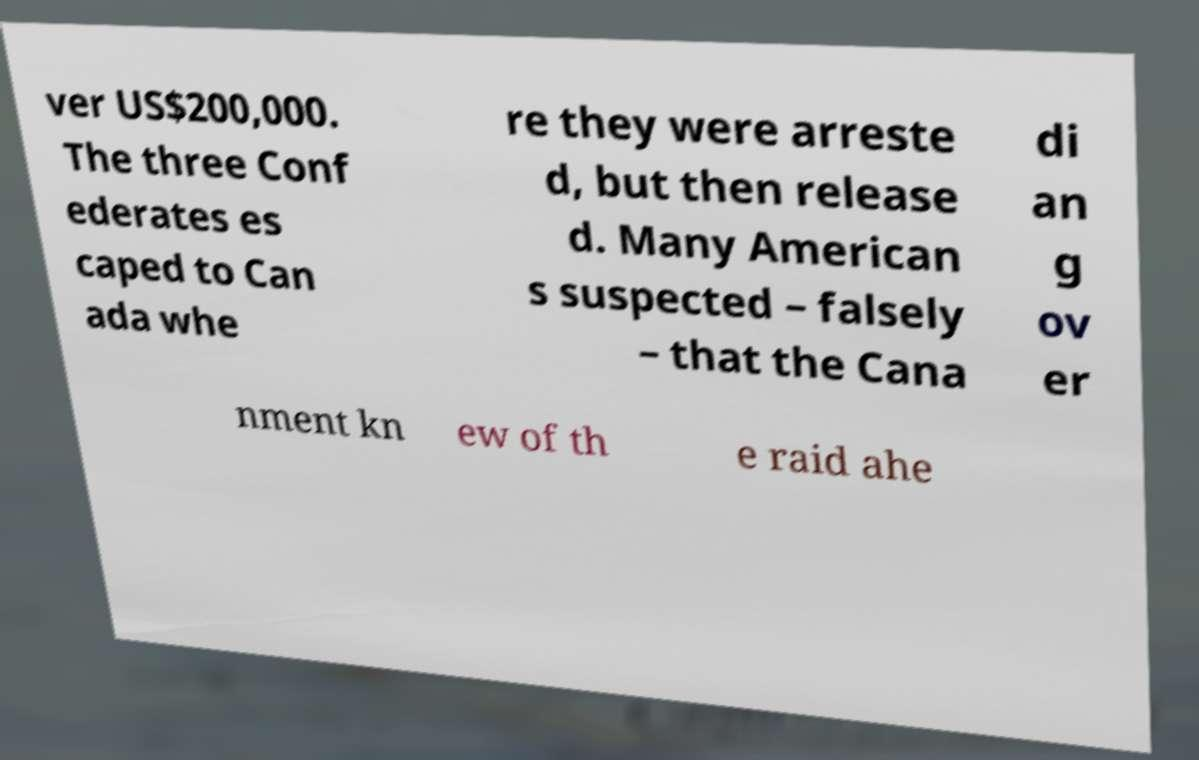Can you read and provide the text displayed in the image?This photo seems to have some interesting text. Can you extract and type it out for me? ver US$200,000. The three Conf ederates es caped to Can ada whe re they were arreste d, but then release d. Many American s suspected – falsely – that the Cana di an g ov er nment kn ew of th e raid ahe 